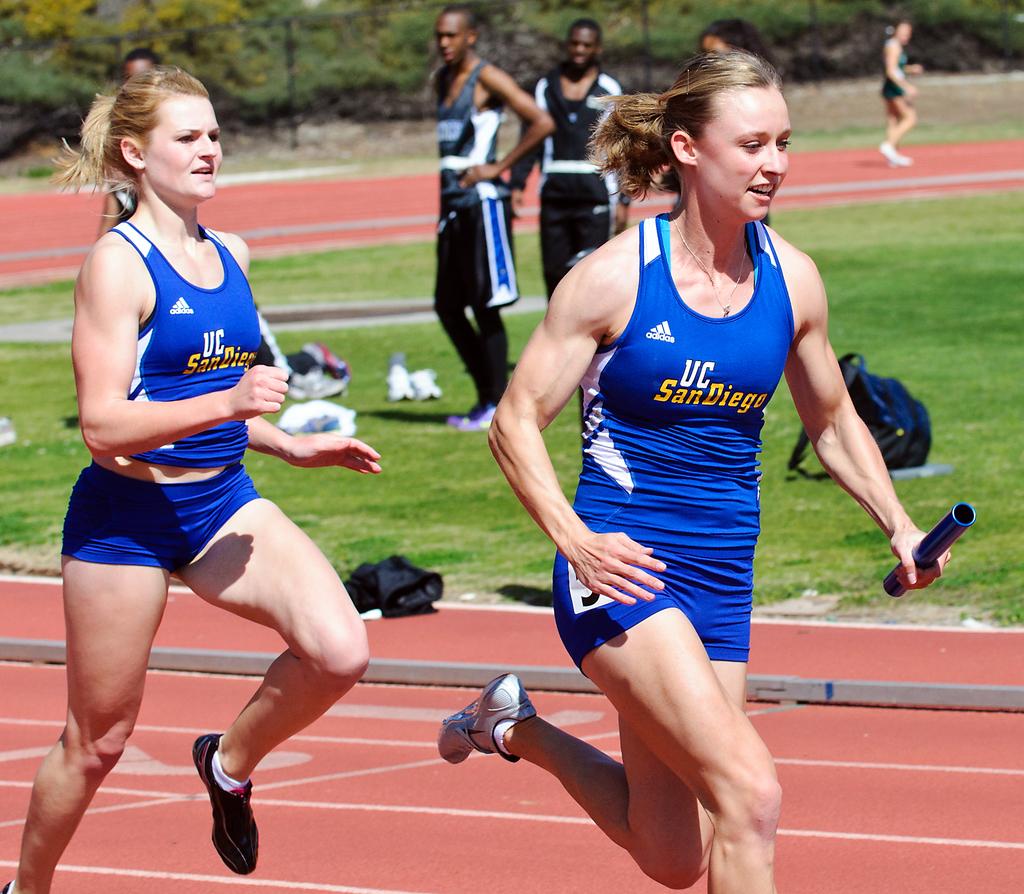What university are these women representing?
Offer a terse response. Uc san diego. What color are the wemons uniforms?
Give a very brief answer. Answering does not require reading text in the image. 